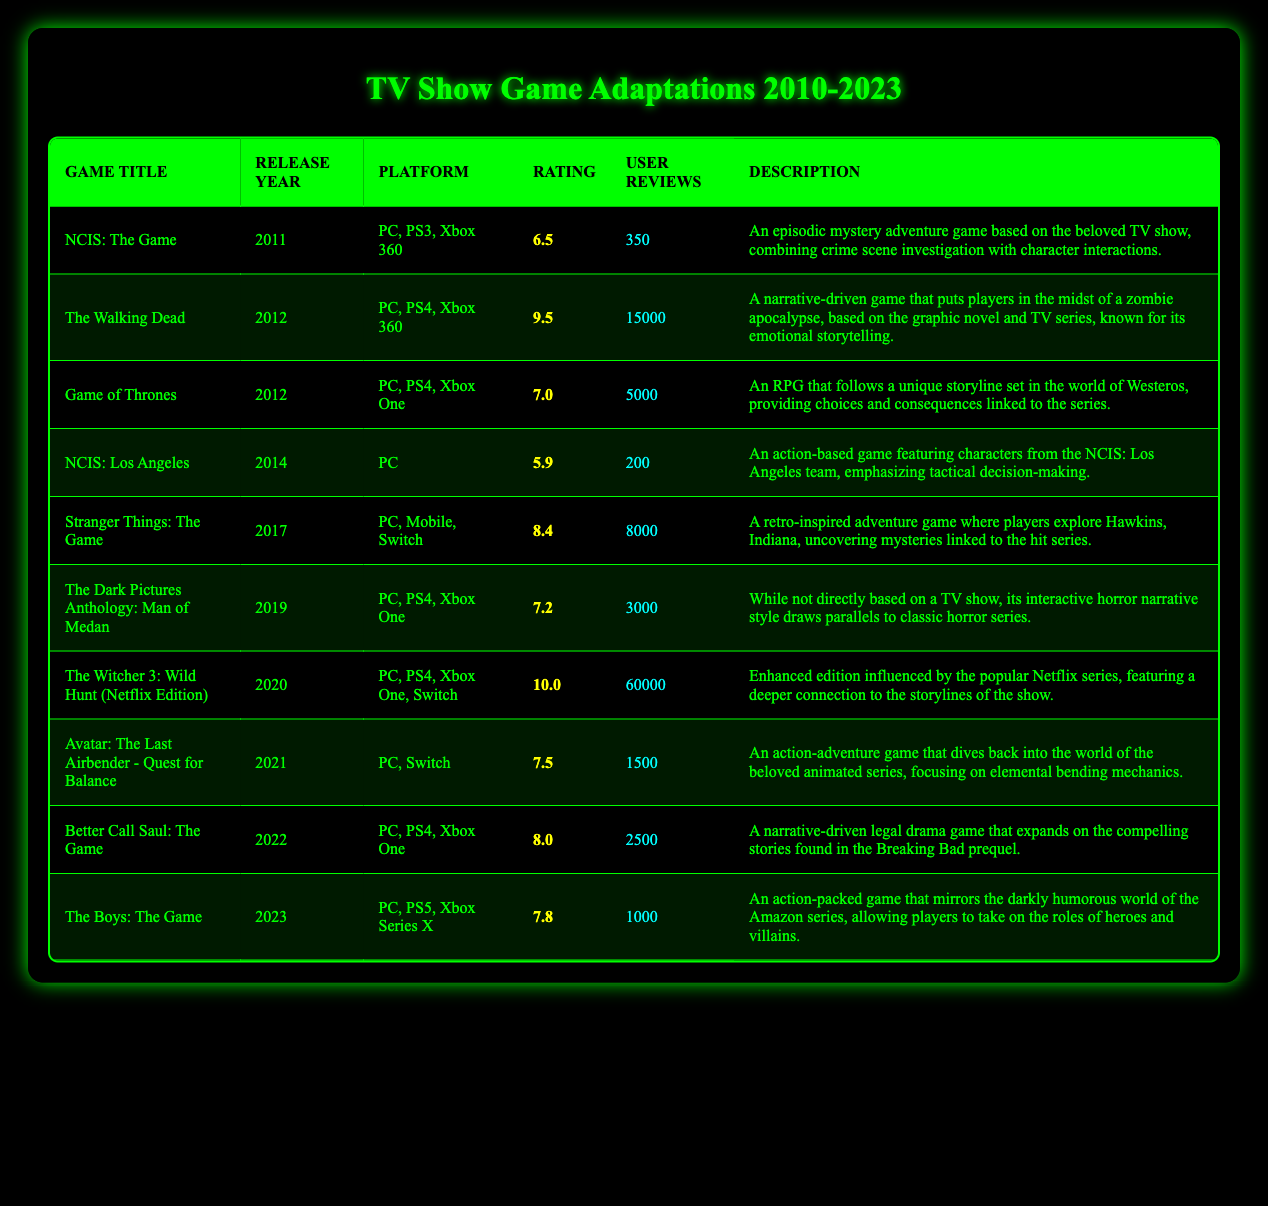What is the highest-rated game based on a TV show? By scanning the "Rating" column in the table, the game with the highest score is "The Witcher 3: Wild Hunt (Netflix Edition)" with a rating of 10.0.
Answer: The Witcher 3: Wild Hunt (Netflix Edition) How many user reviews did "The Walking Dead" receive? In the "User Reviews" column, "The Walking Dead" has 15,000 reviews listed.
Answer: 15,000 Which game was released in 2014? Checking the "Release Year" column, the game listed for 2014 is "NCIS: Los Angeles."
Answer: NCIS: Los Angeles What is the average rating of the games released from 2012 to 2014? The ratings for the games are as follows: "The Walking Dead" (9.5), "Game of Thrones" (7.0), "NCIS: Los Angeles" (5.9). The average rating is calculated as (9.5 + 7.0 + 5.9) / 3 = 7.47.
Answer: 7.47 Is "Stranger Things: The Game" rated higher than "Game of Thrones"? "Stranger Things: The Game" has a rating of 8.4, while "Game of Thrones" has a rating of 7.0. Since 8.4 is greater than 7.0, the statement is true.
Answer: Yes Which game has the fewest user reviews, and how many are there? Looking at the "User Reviews" column, "NCIS: Los Angeles" has the fewest reviews with a count of 200.
Answer: NCIS: Los Angeles, 200 How many games released in 2021 have ratings above 7.0? The only game released in 2021 is "Avatar: The Last Airbender - Quest for Balance," which has a rating of 7.5 (above 7.0). Therefore, there is 1 game meeting the criteria.
Answer: 1 Which platform features "The Boys: The Game"? In the "Platform" column, "The Boys: The Game" is listed for PC, PS5, and Xbox Series X.
Answer: PC, PS5, Xbox Series X What is the difference in user reviews between "The Walking Dead" and "The Boys: The Game"? "The Walking Dead" has 15,000 user reviews, and "The Boys: The Game" has 1,000. The difference is calculated as 15,000 - 1,000 = 14,000.
Answer: 14,000 List all the platforms that had games released in 2012. The games released in 2012 are "The Walking Dead" (PC, PS4, Xbox 360) and "Game of Thrones" (PC, PS4, Xbox One). The platforms used are PC, PS4, Xbox 360, and Xbox One, which summarizes as PC, PS4, Xbox 360, Xbox One.
Answer: PC, PS4, Xbox 360, Xbox One 